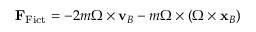<formula> <loc_0><loc_0><loc_500><loc_500>F _ { F i c t } = - 2 m { \Omega } \times v _ { B } - m { \Omega } \times ( { \Omega } \times x _ { B } )</formula> 